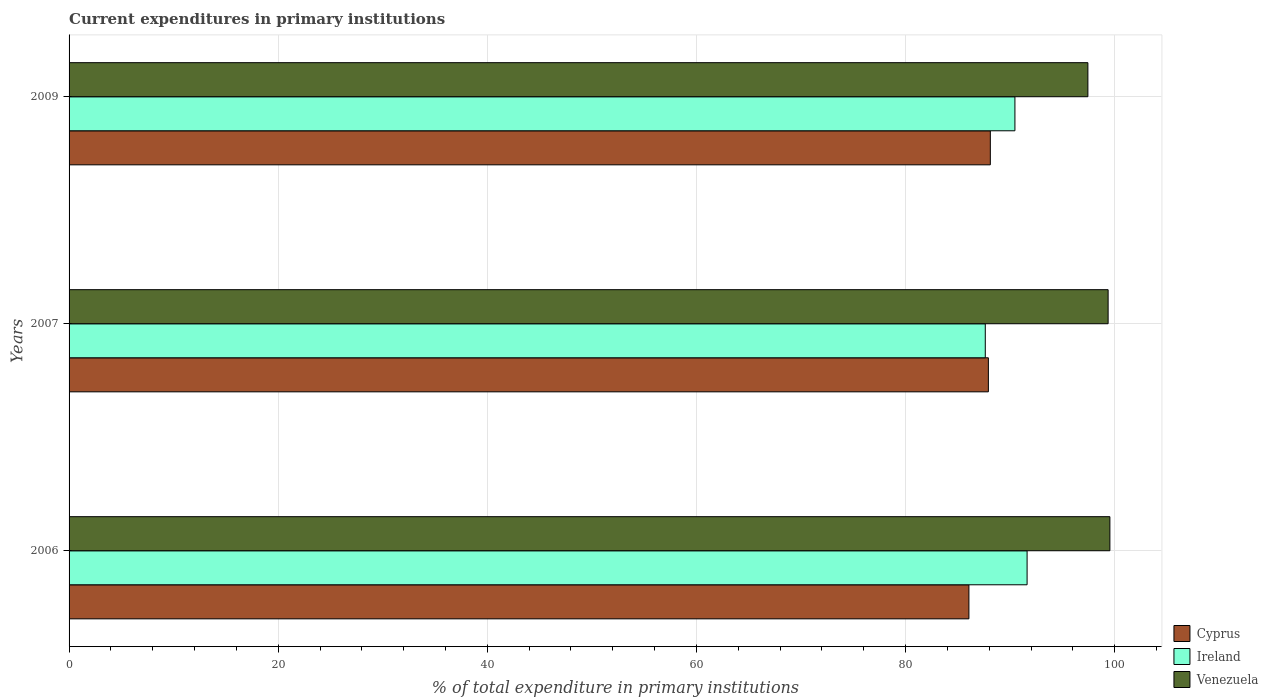Are the number of bars on each tick of the Y-axis equal?
Ensure brevity in your answer.  Yes. How many bars are there on the 3rd tick from the top?
Ensure brevity in your answer.  3. How many bars are there on the 1st tick from the bottom?
Keep it short and to the point. 3. What is the label of the 1st group of bars from the top?
Your answer should be compact. 2009. In how many cases, is the number of bars for a given year not equal to the number of legend labels?
Ensure brevity in your answer.  0. What is the current expenditures in primary institutions in Ireland in 2007?
Keep it short and to the point. 87.62. Across all years, what is the maximum current expenditures in primary institutions in Ireland?
Your response must be concise. 91.62. Across all years, what is the minimum current expenditures in primary institutions in Venezuela?
Your response must be concise. 97.43. In which year was the current expenditures in primary institutions in Ireland maximum?
Ensure brevity in your answer.  2006. In which year was the current expenditures in primary institutions in Cyprus minimum?
Offer a terse response. 2006. What is the total current expenditures in primary institutions in Venezuela in the graph?
Your answer should be compact. 296.34. What is the difference between the current expenditures in primary institutions in Ireland in 2007 and that in 2009?
Your answer should be very brief. -2.84. What is the difference between the current expenditures in primary institutions in Cyprus in 2009 and the current expenditures in primary institutions in Venezuela in 2007?
Make the answer very short. -11.27. What is the average current expenditures in primary institutions in Cyprus per year?
Give a very brief answer. 87.36. In the year 2007, what is the difference between the current expenditures in primary institutions in Cyprus and current expenditures in primary institutions in Ireland?
Your response must be concise. 0.3. What is the ratio of the current expenditures in primary institutions in Venezuela in 2007 to that in 2009?
Give a very brief answer. 1.02. What is the difference between the highest and the second highest current expenditures in primary institutions in Venezuela?
Provide a succinct answer. 0.17. What is the difference between the highest and the lowest current expenditures in primary institutions in Ireland?
Your response must be concise. 4. What does the 3rd bar from the top in 2009 represents?
Your answer should be compact. Cyprus. What does the 1st bar from the bottom in 2006 represents?
Provide a succinct answer. Cyprus. Is it the case that in every year, the sum of the current expenditures in primary institutions in Venezuela and current expenditures in primary institutions in Ireland is greater than the current expenditures in primary institutions in Cyprus?
Ensure brevity in your answer.  Yes. How many bars are there?
Keep it short and to the point. 9. How many years are there in the graph?
Make the answer very short. 3. Does the graph contain any zero values?
Make the answer very short. No. Does the graph contain grids?
Provide a succinct answer. Yes. Where does the legend appear in the graph?
Give a very brief answer. Bottom right. What is the title of the graph?
Your response must be concise. Current expenditures in primary institutions. What is the label or title of the X-axis?
Offer a very short reply. % of total expenditure in primary institutions. What is the % of total expenditure in primary institutions of Cyprus in 2006?
Give a very brief answer. 86.06. What is the % of total expenditure in primary institutions in Ireland in 2006?
Keep it short and to the point. 91.62. What is the % of total expenditure in primary institutions of Venezuela in 2006?
Offer a very short reply. 99.54. What is the % of total expenditure in primary institutions of Cyprus in 2007?
Keep it short and to the point. 87.92. What is the % of total expenditure in primary institutions of Ireland in 2007?
Your response must be concise. 87.62. What is the % of total expenditure in primary institutions of Venezuela in 2007?
Ensure brevity in your answer.  99.37. What is the % of total expenditure in primary institutions in Cyprus in 2009?
Your answer should be compact. 88.1. What is the % of total expenditure in primary institutions in Ireland in 2009?
Ensure brevity in your answer.  90.46. What is the % of total expenditure in primary institutions of Venezuela in 2009?
Your answer should be very brief. 97.43. Across all years, what is the maximum % of total expenditure in primary institutions in Cyprus?
Your response must be concise. 88.1. Across all years, what is the maximum % of total expenditure in primary institutions in Ireland?
Your answer should be compact. 91.62. Across all years, what is the maximum % of total expenditure in primary institutions in Venezuela?
Provide a short and direct response. 99.54. Across all years, what is the minimum % of total expenditure in primary institutions of Cyprus?
Your answer should be very brief. 86.06. Across all years, what is the minimum % of total expenditure in primary institutions in Ireland?
Your answer should be compact. 87.62. Across all years, what is the minimum % of total expenditure in primary institutions in Venezuela?
Keep it short and to the point. 97.43. What is the total % of total expenditure in primary institutions of Cyprus in the graph?
Your response must be concise. 262.08. What is the total % of total expenditure in primary institutions of Ireland in the graph?
Offer a terse response. 269.7. What is the total % of total expenditure in primary institutions in Venezuela in the graph?
Provide a short and direct response. 296.34. What is the difference between the % of total expenditure in primary institutions of Cyprus in 2006 and that in 2007?
Give a very brief answer. -1.86. What is the difference between the % of total expenditure in primary institutions in Ireland in 2006 and that in 2007?
Ensure brevity in your answer.  4. What is the difference between the % of total expenditure in primary institutions of Venezuela in 2006 and that in 2007?
Provide a short and direct response. 0.17. What is the difference between the % of total expenditure in primary institutions in Cyprus in 2006 and that in 2009?
Provide a succinct answer. -2.05. What is the difference between the % of total expenditure in primary institutions in Ireland in 2006 and that in 2009?
Your response must be concise. 1.16. What is the difference between the % of total expenditure in primary institutions of Venezuela in 2006 and that in 2009?
Your answer should be very brief. 2.1. What is the difference between the % of total expenditure in primary institutions in Cyprus in 2007 and that in 2009?
Offer a terse response. -0.19. What is the difference between the % of total expenditure in primary institutions of Ireland in 2007 and that in 2009?
Provide a short and direct response. -2.84. What is the difference between the % of total expenditure in primary institutions of Venezuela in 2007 and that in 2009?
Your answer should be compact. 1.93. What is the difference between the % of total expenditure in primary institutions of Cyprus in 2006 and the % of total expenditure in primary institutions of Ireland in 2007?
Your answer should be very brief. -1.56. What is the difference between the % of total expenditure in primary institutions of Cyprus in 2006 and the % of total expenditure in primary institutions of Venezuela in 2007?
Provide a short and direct response. -13.31. What is the difference between the % of total expenditure in primary institutions in Ireland in 2006 and the % of total expenditure in primary institutions in Venezuela in 2007?
Keep it short and to the point. -7.75. What is the difference between the % of total expenditure in primary institutions of Cyprus in 2006 and the % of total expenditure in primary institutions of Ireland in 2009?
Provide a short and direct response. -4.4. What is the difference between the % of total expenditure in primary institutions of Cyprus in 2006 and the % of total expenditure in primary institutions of Venezuela in 2009?
Your answer should be compact. -11.38. What is the difference between the % of total expenditure in primary institutions of Ireland in 2006 and the % of total expenditure in primary institutions of Venezuela in 2009?
Offer a terse response. -5.81. What is the difference between the % of total expenditure in primary institutions in Cyprus in 2007 and the % of total expenditure in primary institutions in Ireland in 2009?
Your response must be concise. -2.54. What is the difference between the % of total expenditure in primary institutions of Cyprus in 2007 and the % of total expenditure in primary institutions of Venezuela in 2009?
Ensure brevity in your answer.  -9.52. What is the difference between the % of total expenditure in primary institutions in Ireland in 2007 and the % of total expenditure in primary institutions in Venezuela in 2009?
Make the answer very short. -9.81. What is the average % of total expenditure in primary institutions of Cyprus per year?
Provide a succinct answer. 87.36. What is the average % of total expenditure in primary institutions of Ireland per year?
Provide a short and direct response. 89.9. What is the average % of total expenditure in primary institutions of Venezuela per year?
Provide a succinct answer. 98.78. In the year 2006, what is the difference between the % of total expenditure in primary institutions of Cyprus and % of total expenditure in primary institutions of Ireland?
Give a very brief answer. -5.56. In the year 2006, what is the difference between the % of total expenditure in primary institutions in Cyprus and % of total expenditure in primary institutions in Venezuela?
Offer a very short reply. -13.48. In the year 2006, what is the difference between the % of total expenditure in primary institutions in Ireland and % of total expenditure in primary institutions in Venezuela?
Your response must be concise. -7.92. In the year 2007, what is the difference between the % of total expenditure in primary institutions of Cyprus and % of total expenditure in primary institutions of Ireland?
Provide a short and direct response. 0.3. In the year 2007, what is the difference between the % of total expenditure in primary institutions of Cyprus and % of total expenditure in primary institutions of Venezuela?
Offer a very short reply. -11.45. In the year 2007, what is the difference between the % of total expenditure in primary institutions in Ireland and % of total expenditure in primary institutions in Venezuela?
Ensure brevity in your answer.  -11.75. In the year 2009, what is the difference between the % of total expenditure in primary institutions in Cyprus and % of total expenditure in primary institutions in Ireland?
Your answer should be compact. -2.35. In the year 2009, what is the difference between the % of total expenditure in primary institutions of Cyprus and % of total expenditure in primary institutions of Venezuela?
Keep it short and to the point. -9.33. In the year 2009, what is the difference between the % of total expenditure in primary institutions in Ireland and % of total expenditure in primary institutions in Venezuela?
Ensure brevity in your answer.  -6.98. What is the ratio of the % of total expenditure in primary institutions in Cyprus in 2006 to that in 2007?
Keep it short and to the point. 0.98. What is the ratio of the % of total expenditure in primary institutions of Ireland in 2006 to that in 2007?
Offer a very short reply. 1.05. What is the ratio of the % of total expenditure in primary institutions in Venezuela in 2006 to that in 2007?
Provide a short and direct response. 1. What is the ratio of the % of total expenditure in primary institutions in Cyprus in 2006 to that in 2009?
Keep it short and to the point. 0.98. What is the ratio of the % of total expenditure in primary institutions in Ireland in 2006 to that in 2009?
Ensure brevity in your answer.  1.01. What is the ratio of the % of total expenditure in primary institutions in Venezuela in 2006 to that in 2009?
Your answer should be compact. 1.02. What is the ratio of the % of total expenditure in primary institutions of Ireland in 2007 to that in 2009?
Your answer should be very brief. 0.97. What is the ratio of the % of total expenditure in primary institutions in Venezuela in 2007 to that in 2009?
Your response must be concise. 1.02. What is the difference between the highest and the second highest % of total expenditure in primary institutions in Cyprus?
Provide a short and direct response. 0.19. What is the difference between the highest and the second highest % of total expenditure in primary institutions of Ireland?
Make the answer very short. 1.16. What is the difference between the highest and the second highest % of total expenditure in primary institutions in Venezuela?
Offer a terse response. 0.17. What is the difference between the highest and the lowest % of total expenditure in primary institutions of Cyprus?
Ensure brevity in your answer.  2.05. What is the difference between the highest and the lowest % of total expenditure in primary institutions in Ireland?
Your answer should be compact. 4. What is the difference between the highest and the lowest % of total expenditure in primary institutions of Venezuela?
Offer a terse response. 2.1. 